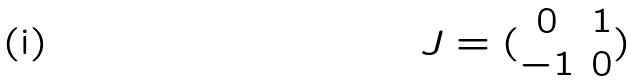<formula> <loc_0><loc_0><loc_500><loc_500>J = ( \begin{matrix} 0 & 1 \\ - 1 & 0 \end{matrix} )</formula> 